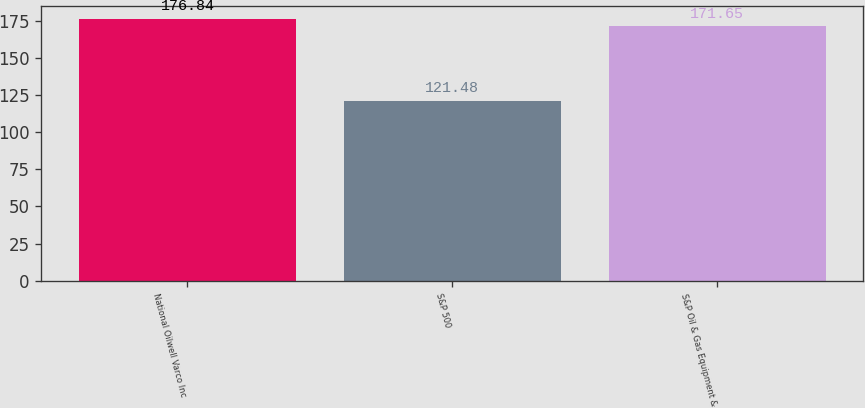Convert chart. <chart><loc_0><loc_0><loc_500><loc_500><bar_chart><fcel>National Oilwell Varco Inc<fcel>S&P 500<fcel>S&P Oil & Gas Equipment &<nl><fcel>176.84<fcel>121.48<fcel>171.65<nl></chart> 